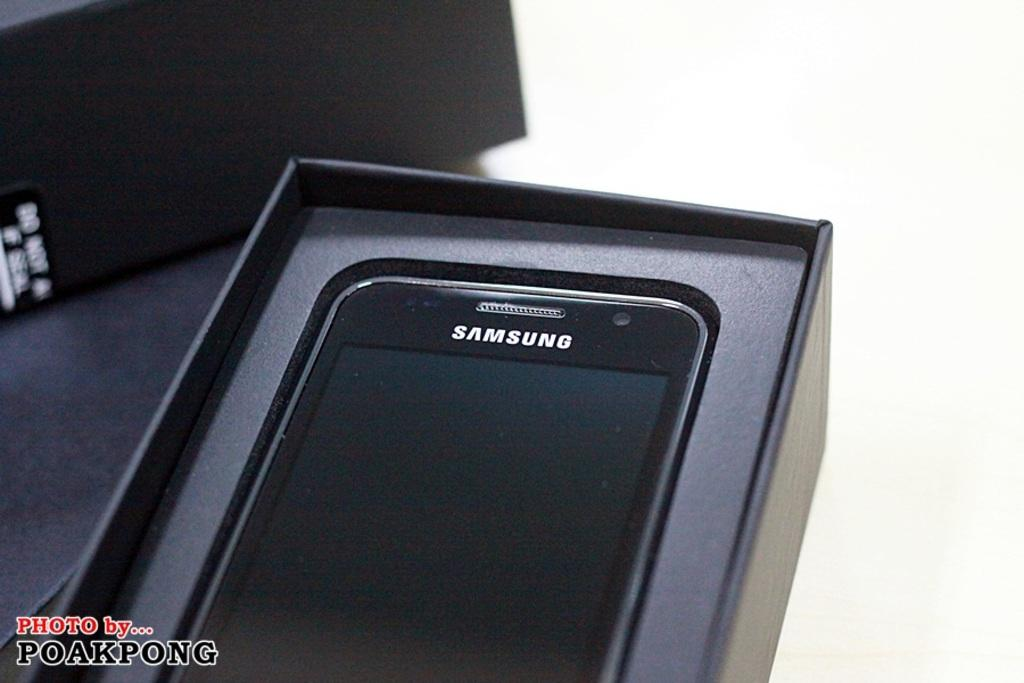<image>
Give a short and clear explanation of the subsequent image. A Samsung phone in an open black case. 